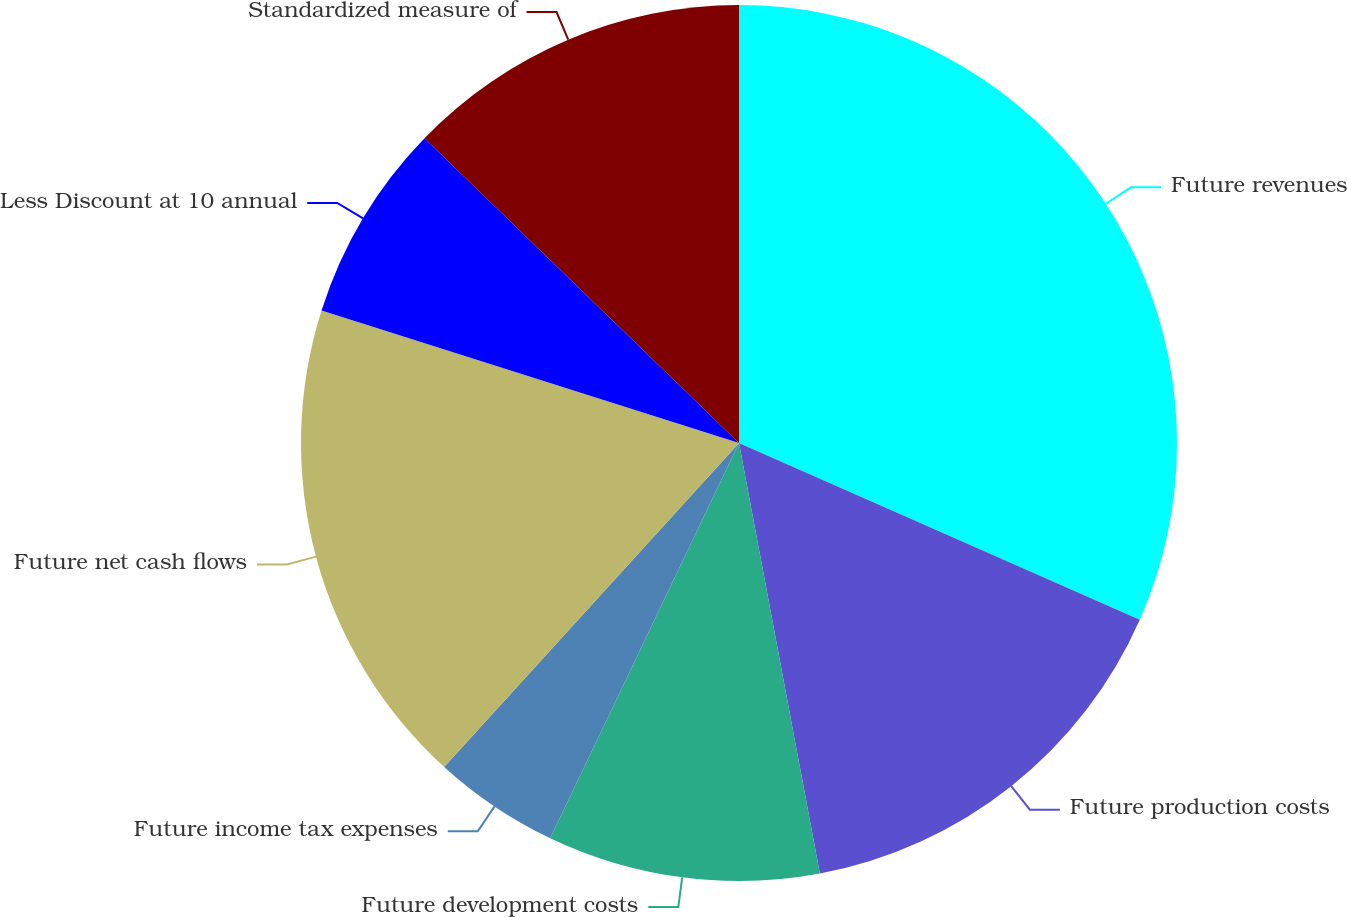<chart> <loc_0><loc_0><loc_500><loc_500><pie_chart><fcel>Future revenues<fcel>Future production costs<fcel>Future development costs<fcel>Future income tax expenses<fcel>Future net cash flows<fcel>Less Discount at 10 annual<fcel>Standardized measure of<nl><fcel>31.61%<fcel>15.44%<fcel>10.05%<fcel>4.66%<fcel>18.14%<fcel>7.36%<fcel>12.75%<nl></chart> 